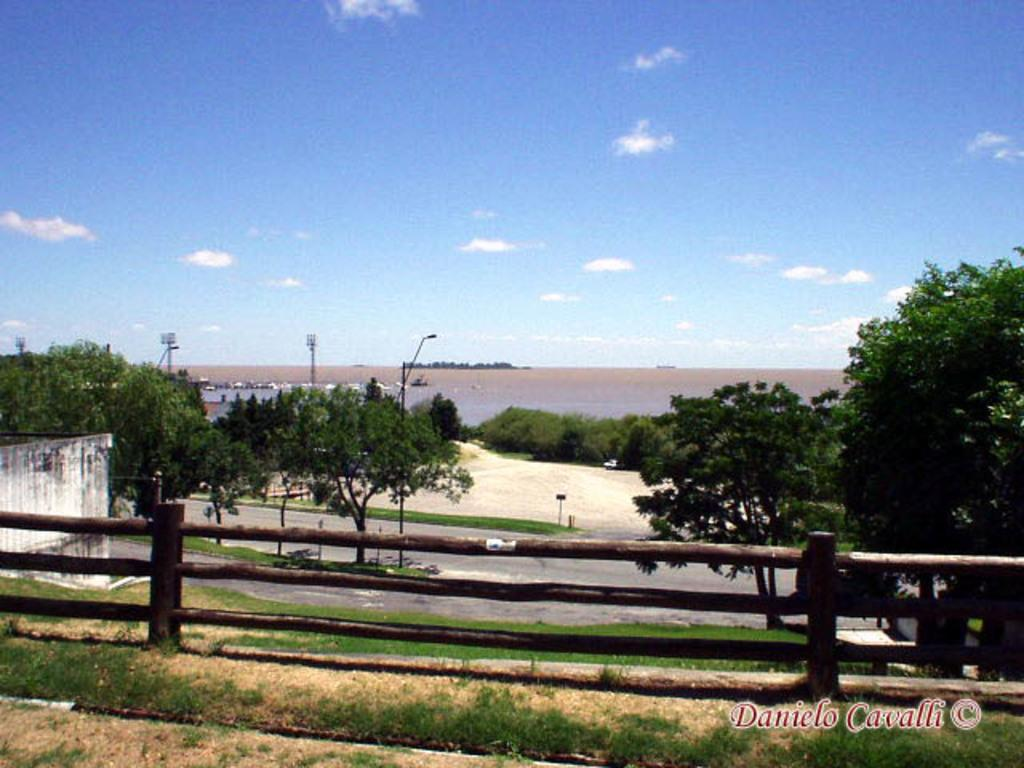What can be seen in the sky in the image? The sky with clouds is visible in the image. What type of natural feature is present in the image? There is a sea in the image. What type of man-made structure is present in the image? A road is present in the image. What type of vegetation is visible in the image? Trees are visible in the image. What type of man-made structures are present in the image? Street poles and street lights are visible in the image. What type of barrier is present in the image? There is a wooden fence in the image. What type of surface is visible in the image? The ground is visible in the image. What type of government is depicted in the image? There is no depiction of a government in the image. What type of clothing item is present in the image? There is no clothing item, such as a mitten, present in the image. 